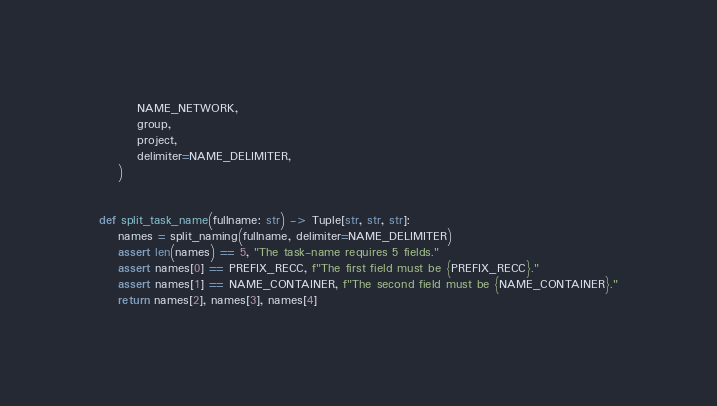Convert code to text. <code><loc_0><loc_0><loc_500><loc_500><_Python_>        NAME_NETWORK,
        group,
        project,
        delimiter=NAME_DELIMITER,
    )


def split_task_name(fullname: str) -> Tuple[str, str, str]:
    names = split_naming(fullname, delimiter=NAME_DELIMITER)
    assert len(names) == 5, "The task-name requires 5 fields."
    assert names[0] == PREFIX_RECC, f"The first field must be {PREFIX_RECC}."
    assert names[1] == NAME_CONTAINER, f"The second field must be {NAME_CONTAINER}."
    return names[2], names[3], names[4]
</code> 